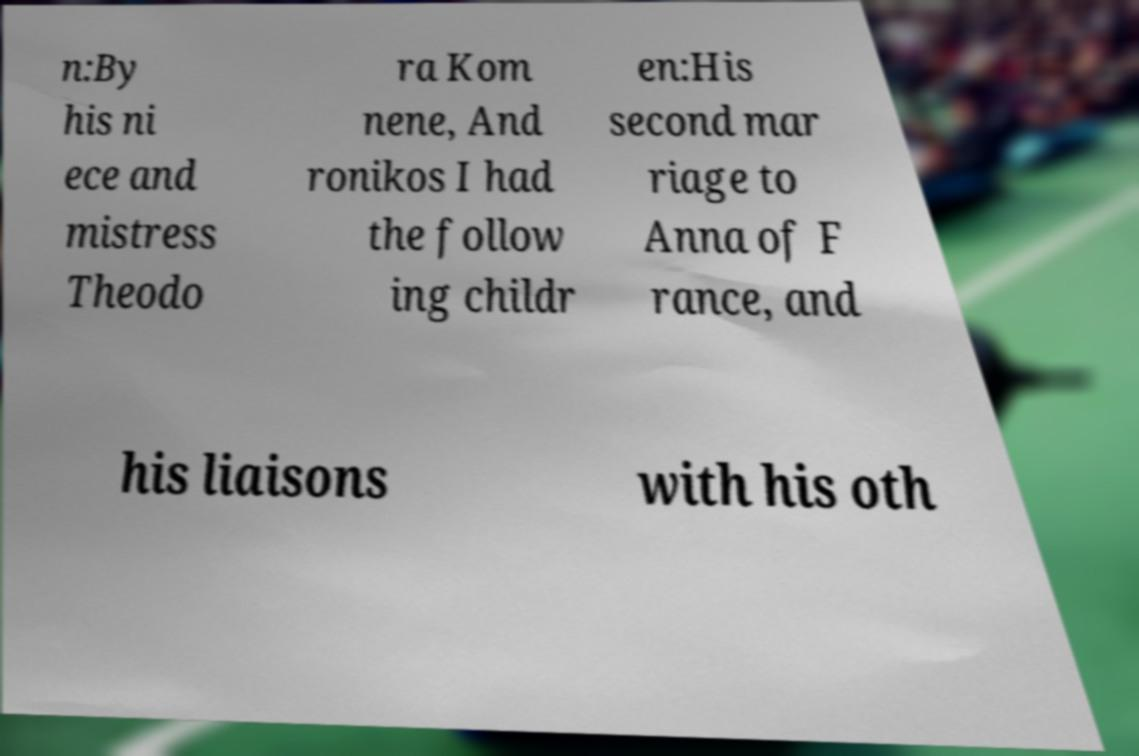Please read and relay the text visible in this image. What does it say? n:By his ni ece and mistress Theodo ra Kom nene, And ronikos I had the follow ing childr en:His second mar riage to Anna of F rance, and his liaisons with his oth 